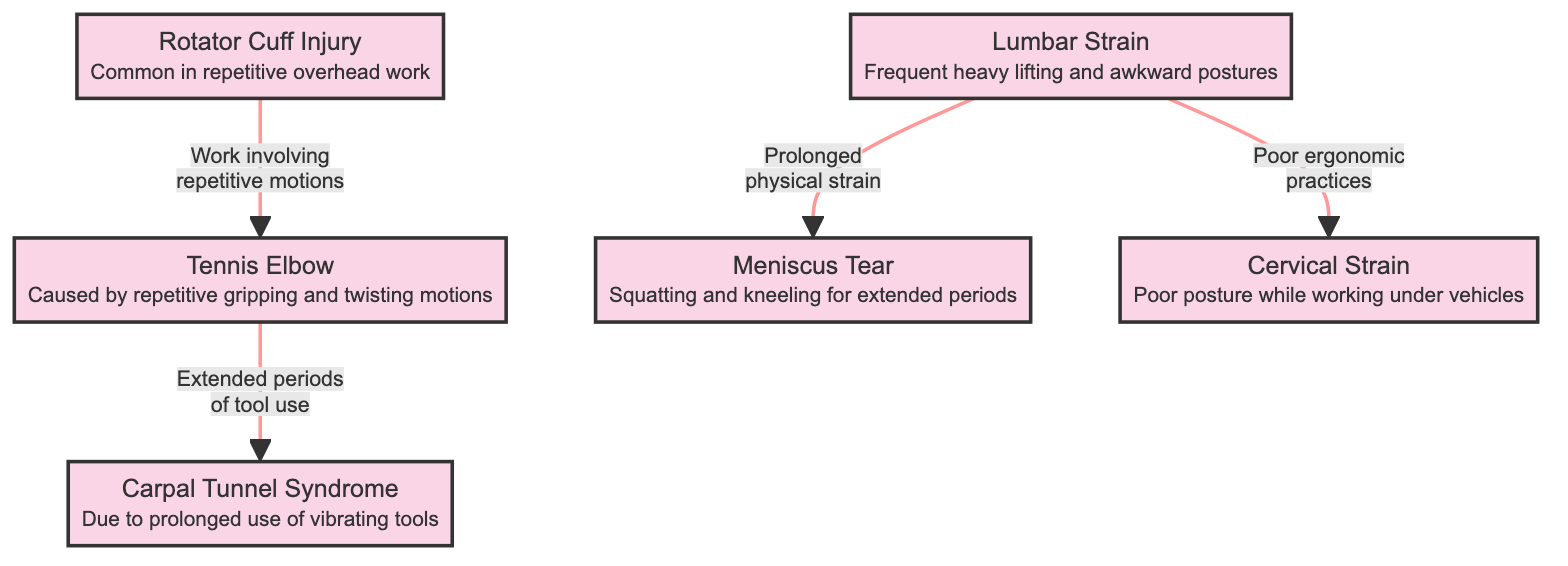What's one type of shoulder injury listed in the diagram? The diagram includes "Rotator Cuff Injury" as a type of shoulder injury.
Answer: Rotator Cuff Injury How many types of joint and muscle injuries are depicted in the diagram? There are a total of six types of injuries shown, including shoulder, elbow, wrist, back, knee, and neck injuries.
Answer: 6 Which injury is caused by "prolonged use of vibrating tools"? The diagram states that "Carpal Tunnel Syndrome" is due to prolonged use of vibrating tools.
Answer: Carpal Tunnel Syndrome What is common in the relationship between shoulder and elbow injuries? The relationship indicates that "work involving repetitive motions" connects shoulder injuries to elbow injuries.
Answer: Work involving repetitive motions Which injury is associated with "poor ergonomic practices"? According to the connections drawn in the diagram, "Cervical Strain" is associated with poor ergonomic practices.
Answer: Cervical Strain How does "Lumbar Strain" relate to "Meniscus Tear"? The diagram indicates that "Lumbar Strain" is caused by prolonged physical strain, which leads to "Meniscus Tear".
Answer: Prolonged physical strain Which injury results from "squatting and kneeling for extended periods"? The diagram specifies that "Meniscus Tear" is the injury that results from squatting and kneeling for extended periods.
Answer: Meniscus Tear What type of injury is "Tennis Elbow"? In the diagram, "Tennis Elbow" is classified as an elbow injury related to repetitive gripping and twisting motions.
Answer: Elbow Injury How does "Cervical Strain" connect to other injuries in the diagram? "Cervical Strain" is connected to "Lumbar Strain" through the cause of poor ergonomic practices, indicating a potential link between neck and back injuries.
Answer: Poor ergonomic practices 